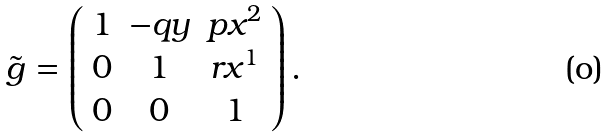Convert formula to latex. <formula><loc_0><loc_0><loc_500><loc_500>\tilde { g } = \left ( \begin{array} { c c c } 1 & - q y & p x ^ { 2 } \\ 0 & 1 & r x ^ { 1 } \\ 0 & 0 & 1 \end{array} \right ) .</formula> 